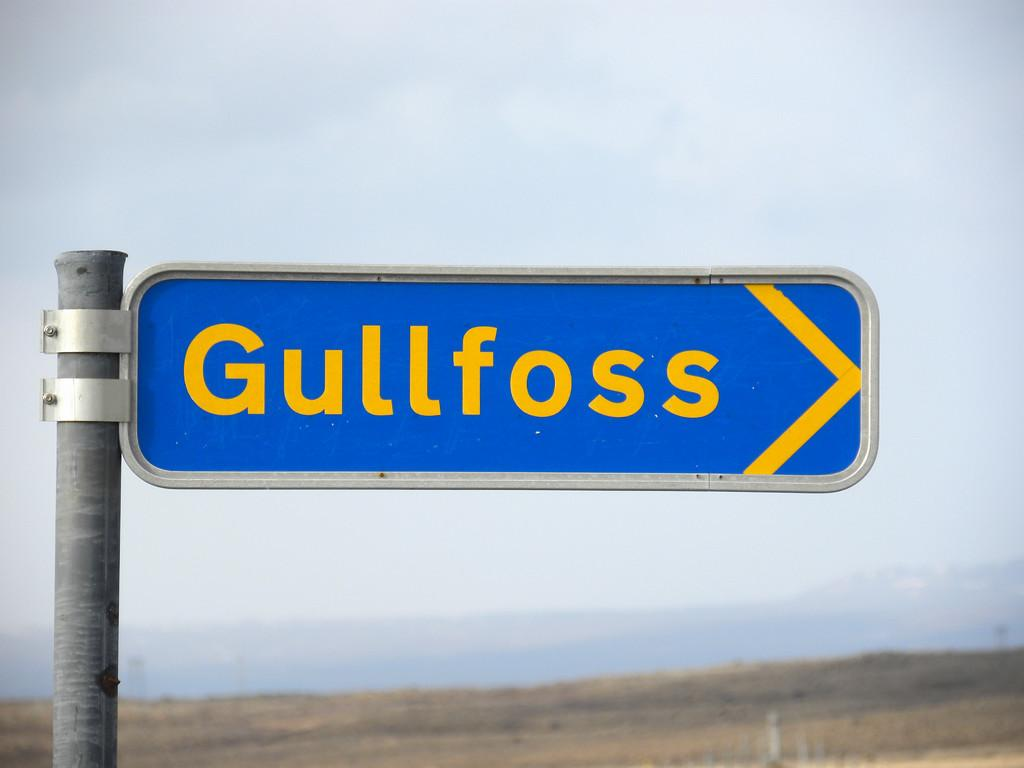<image>
Present a compact description of the photo's key features. A blue road sign for the area of Gullfoss. 